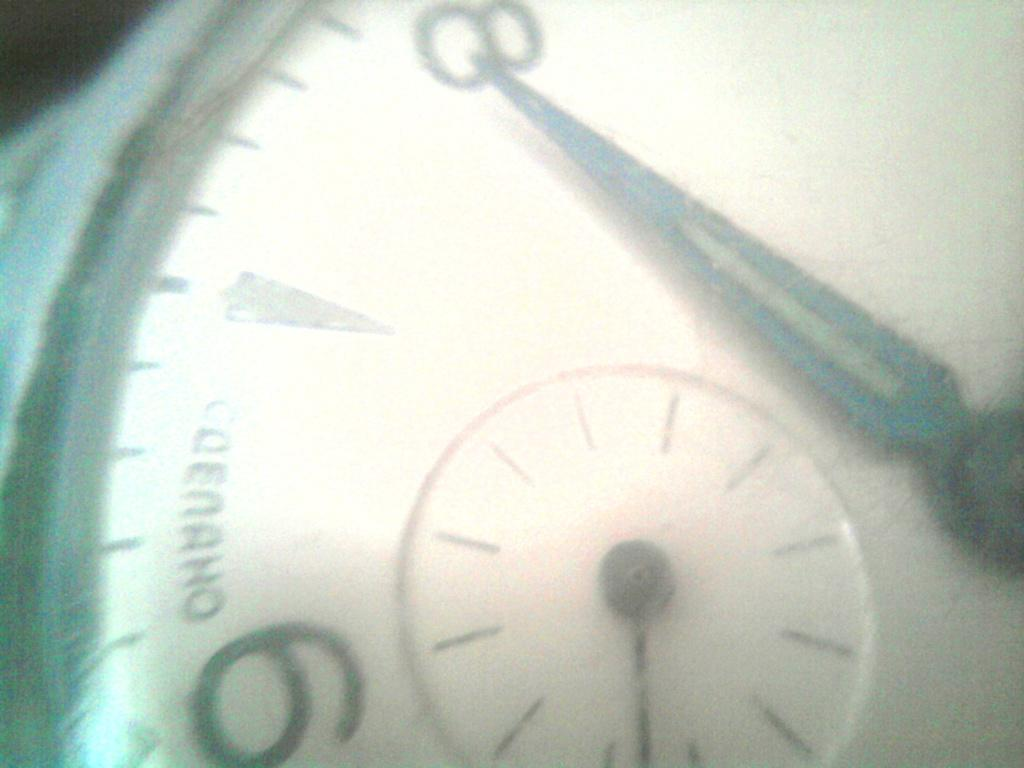What is the main subject of the image? The main subject of the image is the needles of a watch. How many needles are visible in the image? There are two needles visible in the image. What do the needles represent? One needle shows the seconds, and the other needle shows the milliseconds. What type of scene is depicted in the background of the image? There is no background scene depicted in the image, as it focuses solely on the watch's needles. What material is the tin used for in the image? There is no tin present in the image. 